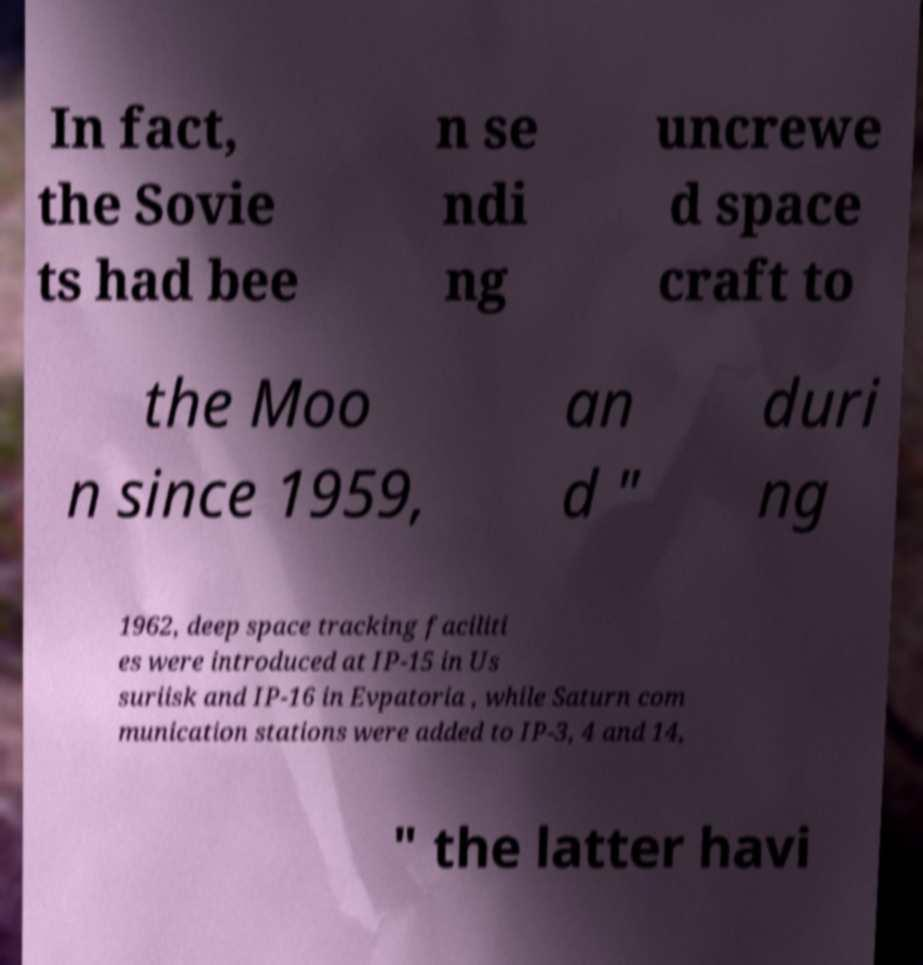Could you extract and type out the text from this image? In fact, the Sovie ts had bee n se ndi ng uncrewe d space craft to the Moo n since 1959, an d " duri ng 1962, deep space tracking faciliti es were introduced at IP-15 in Us suriisk and IP-16 in Evpatoria , while Saturn com munication stations were added to IP-3, 4 and 14, " the latter havi 